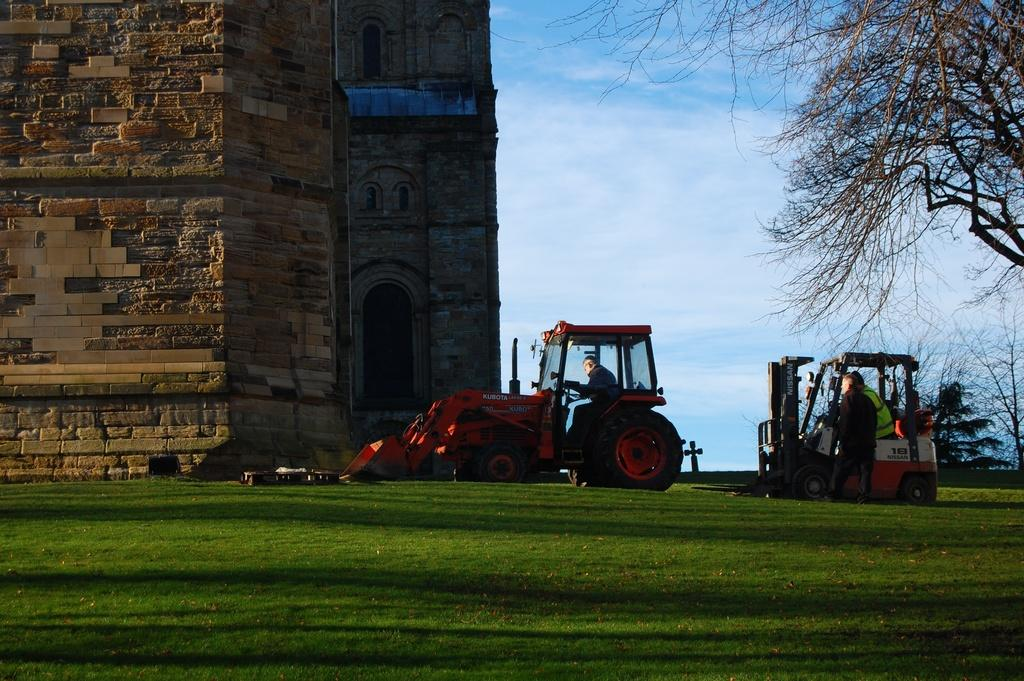What types of objects are in the image? There are vehicles and people in the image. Where are the people and vehicles located? The people and vehicles are on grass in the image. What can be seen in the background of the image? There is a building and a tree in the background of the image. What type of trousers are the people wearing in the image? There is no information about the type of trousers the people are wearing in the image. Is there a gate visible in the image? There is no gate present in the image. 